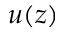Convert formula to latex. <formula><loc_0><loc_0><loc_500><loc_500>u ( z )</formula> 